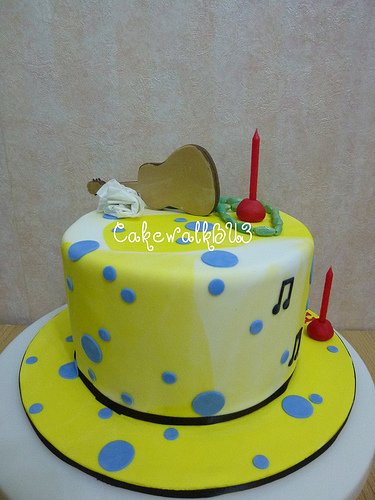<image>
Is there a guitar on the cake? Yes. Looking at the image, I can see the guitar is positioned on top of the cake, with the cake providing support. 